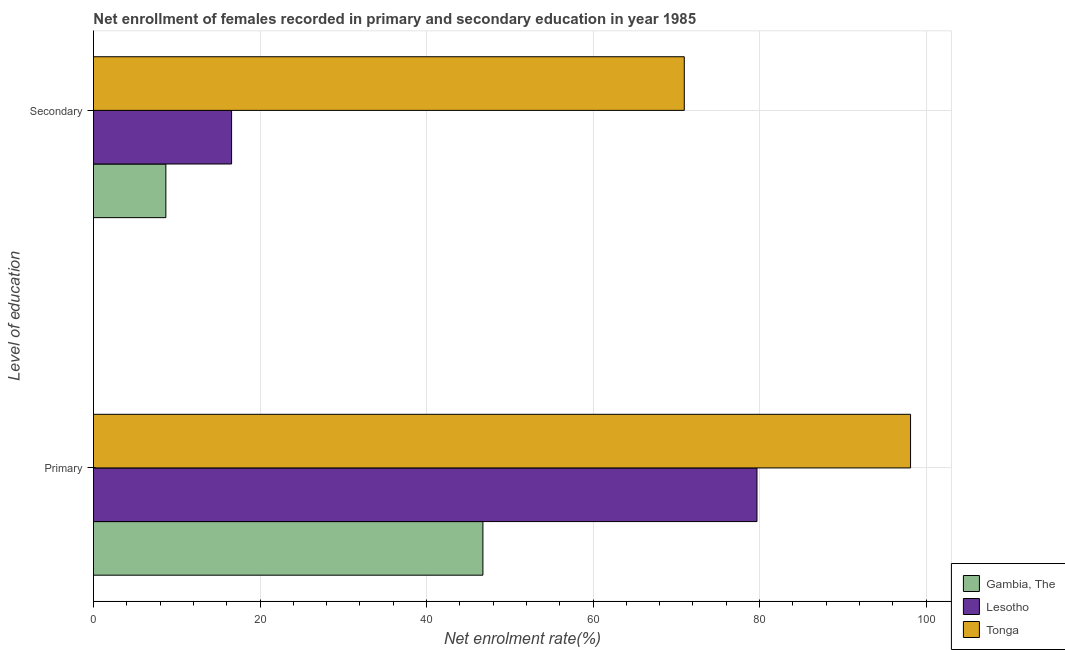How many groups of bars are there?
Ensure brevity in your answer.  2. How many bars are there on the 2nd tick from the bottom?
Offer a terse response. 3. What is the label of the 1st group of bars from the top?
Give a very brief answer. Secondary. What is the enrollment rate in secondary education in Lesotho?
Keep it short and to the point. 16.59. Across all countries, what is the maximum enrollment rate in primary education?
Your answer should be very brief. 98.13. Across all countries, what is the minimum enrollment rate in primary education?
Provide a short and direct response. 46.77. In which country was the enrollment rate in secondary education maximum?
Offer a very short reply. Tonga. In which country was the enrollment rate in secondary education minimum?
Give a very brief answer. Gambia, The. What is the total enrollment rate in secondary education in the graph?
Ensure brevity in your answer.  96.24. What is the difference between the enrollment rate in secondary education in Gambia, The and that in Lesotho?
Keep it short and to the point. -7.9. What is the difference between the enrollment rate in primary education in Gambia, The and the enrollment rate in secondary education in Lesotho?
Your answer should be very brief. 30.18. What is the average enrollment rate in primary education per country?
Ensure brevity in your answer.  74.86. What is the difference between the enrollment rate in secondary education and enrollment rate in primary education in Tonga?
Ensure brevity in your answer.  -27.17. In how many countries, is the enrollment rate in primary education greater than 56 %?
Give a very brief answer. 2. What is the ratio of the enrollment rate in primary education in Lesotho to that in Tonga?
Make the answer very short. 0.81. In how many countries, is the enrollment rate in primary education greater than the average enrollment rate in primary education taken over all countries?
Make the answer very short. 2. What does the 3rd bar from the top in Primary represents?
Provide a short and direct response. Gambia, The. What does the 1st bar from the bottom in Secondary represents?
Offer a terse response. Gambia, The. Are the values on the major ticks of X-axis written in scientific E-notation?
Provide a short and direct response. No. Where does the legend appear in the graph?
Make the answer very short. Bottom right. How are the legend labels stacked?
Make the answer very short. Vertical. What is the title of the graph?
Ensure brevity in your answer.  Net enrollment of females recorded in primary and secondary education in year 1985. Does "Vietnam" appear as one of the legend labels in the graph?
Provide a short and direct response. No. What is the label or title of the X-axis?
Offer a terse response. Net enrolment rate(%). What is the label or title of the Y-axis?
Offer a terse response. Level of education. What is the Net enrolment rate(%) in Gambia, The in Primary?
Give a very brief answer. 46.77. What is the Net enrolment rate(%) in Lesotho in Primary?
Your response must be concise. 79.69. What is the Net enrolment rate(%) of Tonga in Primary?
Ensure brevity in your answer.  98.13. What is the Net enrolment rate(%) in Gambia, The in Secondary?
Your answer should be compact. 8.69. What is the Net enrolment rate(%) in Lesotho in Secondary?
Your answer should be compact. 16.59. What is the Net enrolment rate(%) in Tonga in Secondary?
Make the answer very short. 70.96. Across all Level of education, what is the maximum Net enrolment rate(%) in Gambia, The?
Provide a short and direct response. 46.77. Across all Level of education, what is the maximum Net enrolment rate(%) in Lesotho?
Ensure brevity in your answer.  79.69. Across all Level of education, what is the maximum Net enrolment rate(%) in Tonga?
Give a very brief answer. 98.13. Across all Level of education, what is the minimum Net enrolment rate(%) in Gambia, The?
Offer a terse response. 8.69. Across all Level of education, what is the minimum Net enrolment rate(%) in Lesotho?
Provide a short and direct response. 16.59. Across all Level of education, what is the minimum Net enrolment rate(%) in Tonga?
Offer a very short reply. 70.96. What is the total Net enrolment rate(%) in Gambia, The in the graph?
Provide a short and direct response. 55.46. What is the total Net enrolment rate(%) of Lesotho in the graph?
Your answer should be very brief. 96.27. What is the total Net enrolment rate(%) in Tonga in the graph?
Your answer should be very brief. 169.08. What is the difference between the Net enrolment rate(%) of Gambia, The in Primary and that in Secondary?
Your answer should be compact. 38.08. What is the difference between the Net enrolment rate(%) of Lesotho in Primary and that in Secondary?
Make the answer very short. 63.1. What is the difference between the Net enrolment rate(%) of Tonga in Primary and that in Secondary?
Your response must be concise. 27.17. What is the difference between the Net enrolment rate(%) of Gambia, The in Primary and the Net enrolment rate(%) of Lesotho in Secondary?
Provide a short and direct response. 30.18. What is the difference between the Net enrolment rate(%) in Gambia, The in Primary and the Net enrolment rate(%) in Tonga in Secondary?
Keep it short and to the point. -24.19. What is the difference between the Net enrolment rate(%) in Lesotho in Primary and the Net enrolment rate(%) in Tonga in Secondary?
Your response must be concise. 8.73. What is the average Net enrolment rate(%) in Gambia, The per Level of education?
Make the answer very short. 27.73. What is the average Net enrolment rate(%) of Lesotho per Level of education?
Make the answer very short. 48.14. What is the average Net enrolment rate(%) of Tonga per Level of education?
Keep it short and to the point. 84.54. What is the difference between the Net enrolment rate(%) in Gambia, The and Net enrolment rate(%) in Lesotho in Primary?
Provide a short and direct response. -32.92. What is the difference between the Net enrolment rate(%) in Gambia, The and Net enrolment rate(%) in Tonga in Primary?
Your answer should be very brief. -51.36. What is the difference between the Net enrolment rate(%) in Lesotho and Net enrolment rate(%) in Tonga in Primary?
Your response must be concise. -18.44. What is the difference between the Net enrolment rate(%) in Gambia, The and Net enrolment rate(%) in Lesotho in Secondary?
Ensure brevity in your answer.  -7.9. What is the difference between the Net enrolment rate(%) in Gambia, The and Net enrolment rate(%) in Tonga in Secondary?
Your answer should be very brief. -62.26. What is the difference between the Net enrolment rate(%) of Lesotho and Net enrolment rate(%) of Tonga in Secondary?
Offer a very short reply. -54.37. What is the ratio of the Net enrolment rate(%) of Gambia, The in Primary to that in Secondary?
Make the answer very short. 5.38. What is the ratio of the Net enrolment rate(%) in Lesotho in Primary to that in Secondary?
Provide a succinct answer. 4.8. What is the ratio of the Net enrolment rate(%) in Tonga in Primary to that in Secondary?
Offer a very short reply. 1.38. What is the difference between the highest and the second highest Net enrolment rate(%) in Gambia, The?
Give a very brief answer. 38.08. What is the difference between the highest and the second highest Net enrolment rate(%) in Lesotho?
Offer a very short reply. 63.1. What is the difference between the highest and the second highest Net enrolment rate(%) of Tonga?
Your response must be concise. 27.17. What is the difference between the highest and the lowest Net enrolment rate(%) in Gambia, The?
Your response must be concise. 38.08. What is the difference between the highest and the lowest Net enrolment rate(%) of Lesotho?
Your response must be concise. 63.1. What is the difference between the highest and the lowest Net enrolment rate(%) in Tonga?
Keep it short and to the point. 27.17. 